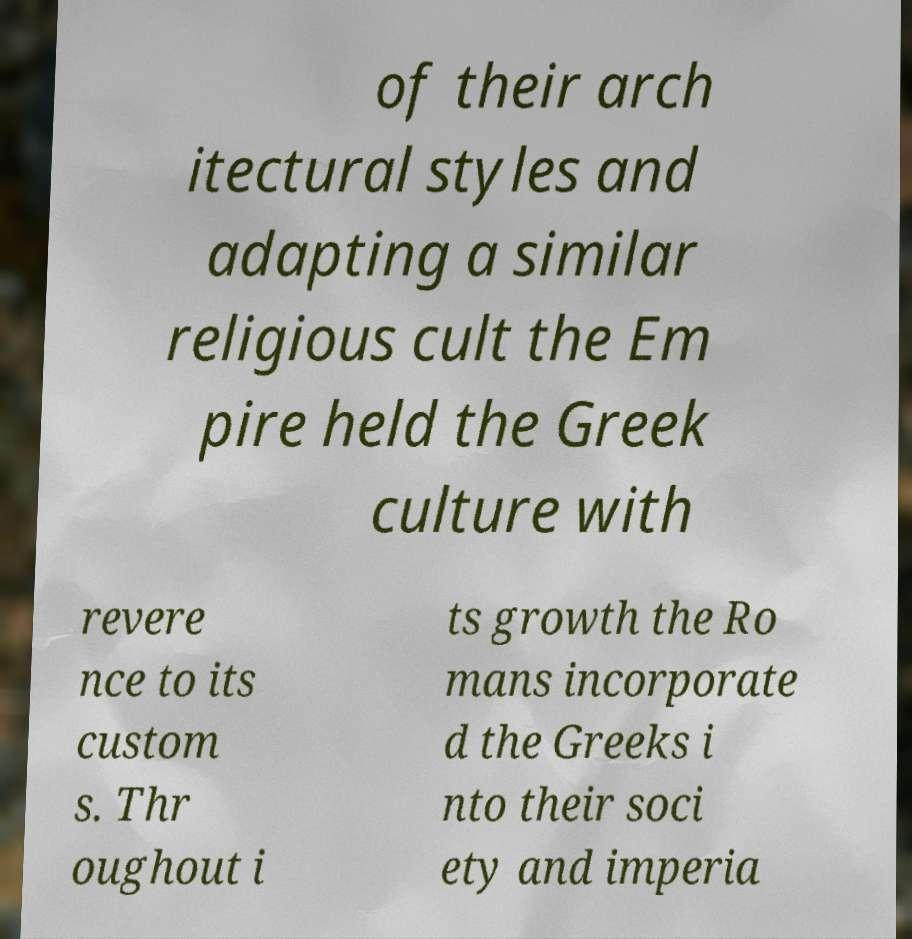I need the written content from this picture converted into text. Can you do that? of their arch itectural styles and adapting a similar religious cult the Em pire held the Greek culture with revere nce to its custom s. Thr oughout i ts growth the Ro mans incorporate d the Greeks i nto their soci ety and imperia 